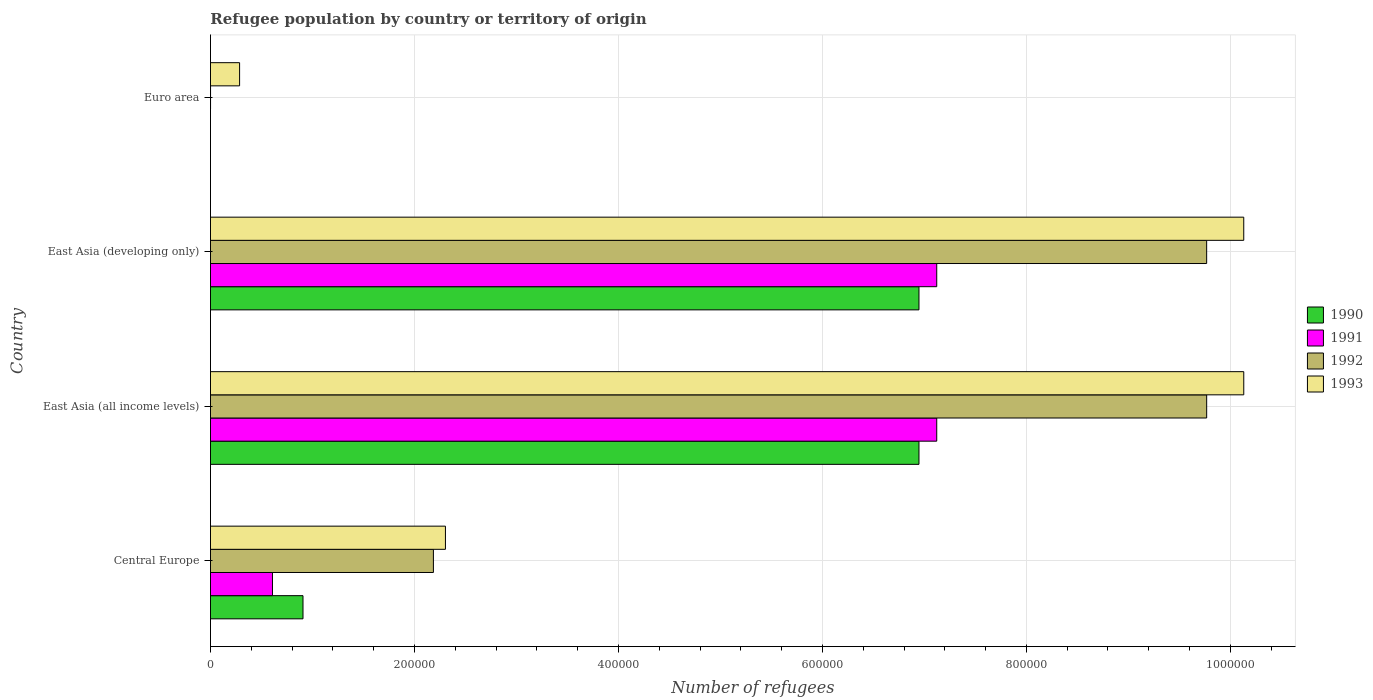How many different coloured bars are there?
Offer a very short reply. 4. Are the number of bars per tick equal to the number of legend labels?
Your answer should be very brief. Yes. Are the number of bars on each tick of the Y-axis equal?
Your response must be concise. Yes. What is the label of the 4th group of bars from the top?
Keep it short and to the point. Central Europe. In how many cases, is the number of bars for a given country not equal to the number of legend labels?
Keep it short and to the point. 0. What is the number of refugees in 1990 in East Asia (developing only)?
Give a very brief answer. 6.95e+05. Across all countries, what is the maximum number of refugees in 1992?
Offer a terse response. 9.77e+05. Across all countries, what is the minimum number of refugees in 1992?
Ensure brevity in your answer.  78. In which country was the number of refugees in 1993 maximum?
Keep it short and to the point. East Asia (all income levels). What is the total number of refugees in 1991 in the graph?
Your answer should be very brief. 1.48e+06. What is the difference between the number of refugees in 1991 in Central Europe and that in Euro area?
Your response must be concise. 6.08e+04. What is the difference between the number of refugees in 1991 in Euro area and the number of refugees in 1990 in Central Europe?
Your answer should be very brief. -9.07e+04. What is the average number of refugees in 1990 per country?
Offer a very short reply. 3.70e+05. What is the difference between the number of refugees in 1992 and number of refugees in 1990 in Central Europe?
Offer a very short reply. 1.28e+05. What is the ratio of the number of refugees in 1993 in East Asia (all income levels) to that in East Asia (developing only)?
Offer a very short reply. 1. What is the difference between the highest and the lowest number of refugees in 1991?
Keep it short and to the point. 7.12e+05. In how many countries, is the number of refugees in 1993 greater than the average number of refugees in 1993 taken over all countries?
Keep it short and to the point. 2. Is the sum of the number of refugees in 1993 in East Asia (developing only) and Euro area greater than the maximum number of refugees in 1990 across all countries?
Provide a short and direct response. Yes. Is it the case that in every country, the sum of the number of refugees in 1990 and number of refugees in 1991 is greater than the sum of number of refugees in 1993 and number of refugees in 1992?
Ensure brevity in your answer.  No. What does the 4th bar from the top in Central Europe represents?
Give a very brief answer. 1990. How many bars are there?
Offer a terse response. 16. Are all the bars in the graph horizontal?
Give a very brief answer. Yes. How many countries are there in the graph?
Provide a short and direct response. 4. Are the values on the major ticks of X-axis written in scientific E-notation?
Provide a short and direct response. No. Does the graph contain grids?
Your response must be concise. Yes. How many legend labels are there?
Offer a very short reply. 4. How are the legend labels stacked?
Ensure brevity in your answer.  Vertical. What is the title of the graph?
Your answer should be very brief. Refugee population by country or territory of origin. Does "1968" appear as one of the legend labels in the graph?
Ensure brevity in your answer.  No. What is the label or title of the X-axis?
Offer a very short reply. Number of refugees. What is the Number of refugees in 1990 in Central Europe?
Give a very brief answer. 9.07e+04. What is the Number of refugees in 1991 in Central Europe?
Your answer should be very brief. 6.08e+04. What is the Number of refugees of 1992 in Central Europe?
Offer a very short reply. 2.19e+05. What is the Number of refugees in 1993 in Central Europe?
Your answer should be compact. 2.30e+05. What is the Number of refugees of 1990 in East Asia (all income levels)?
Your answer should be compact. 6.95e+05. What is the Number of refugees in 1991 in East Asia (all income levels)?
Your response must be concise. 7.12e+05. What is the Number of refugees in 1992 in East Asia (all income levels)?
Keep it short and to the point. 9.77e+05. What is the Number of refugees in 1993 in East Asia (all income levels)?
Your answer should be compact. 1.01e+06. What is the Number of refugees of 1990 in East Asia (developing only)?
Keep it short and to the point. 6.95e+05. What is the Number of refugees in 1991 in East Asia (developing only)?
Provide a short and direct response. 7.12e+05. What is the Number of refugees of 1992 in East Asia (developing only)?
Offer a very short reply. 9.77e+05. What is the Number of refugees in 1993 in East Asia (developing only)?
Provide a short and direct response. 1.01e+06. What is the Number of refugees in 1993 in Euro area?
Give a very brief answer. 2.86e+04. Across all countries, what is the maximum Number of refugees of 1990?
Your response must be concise. 6.95e+05. Across all countries, what is the maximum Number of refugees in 1991?
Ensure brevity in your answer.  7.12e+05. Across all countries, what is the maximum Number of refugees of 1992?
Provide a succinct answer. 9.77e+05. Across all countries, what is the maximum Number of refugees in 1993?
Your response must be concise. 1.01e+06. Across all countries, what is the minimum Number of refugees in 1991?
Your response must be concise. 17. Across all countries, what is the minimum Number of refugees in 1992?
Give a very brief answer. 78. Across all countries, what is the minimum Number of refugees in 1993?
Your answer should be very brief. 2.86e+04. What is the total Number of refugees in 1990 in the graph?
Your response must be concise. 1.48e+06. What is the total Number of refugees in 1991 in the graph?
Offer a terse response. 1.48e+06. What is the total Number of refugees of 1992 in the graph?
Provide a succinct answer. 2.17e+06. What is the total Number of refugees in 1993 in the graph?
Your response must be concise. 2.29e+06. What is the difference between the Number of refugees in 1990 in Central Europe and that in East Asia (all income levels)?
Keep it short and to the point. -6.04e+05. What is the difference between the Number of refugees in 1991 in Central Europe and that in East Asia (all income levels)?
Your answer should be compact. -6.51e+05. What is the difference between the Number of refugees of 1992 in Central Europe and that in East Asia (all income levels)?
Provide a short and direct response. -7.58e+05. What is the difference between the Number of refugees in 1993 in Central Europe and that in East Asia (all income levels)?
Keep it short and to the point. -7.83e+05. What is the difference between the Number of refugees of 1990 in Central Europe and that in East Asia (developing only)?
Ensure brevity in your answer.  -6.04e+05. What is the difference between the Number of refugees of 1991 in Central Europe and that in East Asia (developing only)?
Give a very brief answer. -6.51e+05. What is the difference between the Number of refugees in 1992 in Central Europe and that in East Asia (developing only)?
Ensure brevity in your answer.  -7.58e+05. What is the difference between the Number of refugees of 1993 in Central Europe and that in East Asia (developing only)?
Keep it short and to the point. -7.83e+05. What is the difference between the Number of refugees in 1990 in Central Europe and that in Euro area?
Provide a short and direct response. 9.07e+04. What is the difference between the Number of refugees in 1991 in Central Europe and that in Euro area?
Make the answer very short. 6.08e+04. What is the difference between the Number of refugees in 1992 in Central Europe and that in Euro area?
Provide a short and direct response. 2.19e+05. What is the difference between the Number of refugees of 1993 in Central Europe and that in Euro area?
Give a very brief answer. 2.02e+05. What is the difference between the Number of refugees in 1990 in East Asia (all income levels) and that in East Asia (developing only)?
Give a very brief answer. 0. What is the difference between the Number of refugees of 1991 in East Asia (all income levels) and that in East Asia (developing only)?
Your answer should be very brief. 5. What is the difference between the Number of refugees in 1990 in East Asia (all income levels) and that in Euro area?
Offer a very short reply. 6.95e+05. What is the difference between the Number of refugees of 1991 in East Asia (all income levels) and that in Euro area?
Offer a very short reply. 7.12e+05. What is the difference between the Number of refugees of 1992 in East Asia (all income levels) and that in Euro area?
Your answer should be very brief. 9.77e+05. What is the difference between the Number of refugees of 1993 in East Asia (all income levels) and that in Euro area?
Your response must be concise. 9.85e+05. What is the difference between the Number of refugees in 1990 in East Asia (developing only) and that in Euro area?
Your answer should be very brief. 6.95e+05. What is the difference between the Number of refugees of 1991 in East Asia (developing only) and that in Euro area?
Provide a succinct answer. 7.12e+05. What is the difference between the Number of refugees of 1992 in East Asia (developing only) and that in Euro area?
Your response must be concise. 9.77e+05. What is the difference between the Number of refugees of 1993 in East Asia (developing only) and that in Euro area?
Offer a terse response. 9.85e+05. What is the difference between the Number of refugees of 1990 in Central Europe and the Number of refugees of 1991 in East Asia (all income levels)?
Ensure brevity in your answer.  -6.21e+05. What is the difference between the Number of refugees of 1990 in Central Europe and the Number of refugees of 1992 in East Asia (all income levels)?
Offer a very short reply. -8.86e+05. What is the difference between the Number of refugees of 1990 in Central Europe and the Number of refugees of 1993 in East Asia (all income levels)?
Keep it short and to the point. -9.22e+05. What is the difference between the Number of refugees of 1991 in Central Europe and the Number of refugees of 1992 in East Asia (all income levels)?
Your answer should be compact. -9.16e+05. What is the difference between the Number of refugees of 1991 in Central Europe and the Number of refugees of 1993 in East Asia (all income levels)?
Ensure brevity in your answer.  -9.52e+05. What is the difference between the Number of refugees of 1992 in Central Europe and the Number of refugees of 1993 in East Asia (all income levels)?
Your answer should be very brief. -7.95e+05. What is the difference between the Number of refugees of 1990 in Central Europe and the Number of refugees of 1991 in East Asia (developing only)?
Make the answer very short. -6.21e+05. What is the difference between the Number of refugees of 1990 in Central Europe and the Number of refugees of 1992 in East Asia (developing only)?
Your answer should be very brief. -8.86e+05. What is the difference between the Number of refugees of 1990 in Central Europe and the Number of refugees of 1993 in East Asia (developing only)?
Your answer should be very brief. -9.22e+05. What is the difference between the Number of refugees of 1991 in Central Europe and the Number of refugees of 1992 in East Asia (developing only)?
Keep it short and to the point. -9.16e+05. What is the difference between the Number of refugees in 1991 in Central Europe and the Number of refugees in 1993 in East Asia (developing only)?
Make the answer very short. -9.52e+05. What is the difference between the Number of refugees in 1992 in Central Europe and the Number of refugees in 1993 in East Asia (developing only)?
Provide a succinct answer. -7.95e+05. What is the difference between the Number of refugees in 1990 in Central Europe and the Number of refugees in 1991 in Euro area?
Your response must be concise. 9.07e+04. What is the difference between the Number of refugees in 1990 in Central Europe and the Number of refugees in 1992 in Euro area?
Ensure brevity in your answer.  9.07e+04. What is the difference between the Number of refugees in 1990 in Central Europe and the Number of refugees in 1993 in Euro area?
Keep it short and to the point. 6.22e+04. What is the difference between the Number of refugees of 1991 in Central Europe and the Number of refugees of 1992 in Euro area?
Your response must be concise. 6.07e+04. What is the difference between the Number of refugees of 1991 in Central Europe and the Number of refugees of 1993 in Euro area?
Your answer should be very brief. 3.22e+04. What is the difference between the Number of refugees of 1992 in Central Europe and the Number of refugees of 1993 in Euro area?
Provide a succinct answer. 1.90e+05. What is the difference between the Number of refugees of 1990 in East Asia (all income levels) and the Number of refugees of 1991 in East Asia (developing only)?
Your response must be concise. -1.74e+04. What is the difference between the Number of refugees of 1990 in East Asia (all income levels) and the Number of refugees of 1992 in East Asia (developing only)?
Provide a short and direct response. -2.82e+05. What is the difference between the Number of refugees of 1990 in East Asia (all income levels) and the Number of refugees of 1993 in East Asia (developing only)?
Provide a succinct answer. -3.18e+05. What is the difference between the Number of refugees in 1991 in East Asia (all income levels) and the Number of refugees in 1992 in East Asia (developing only)?
Provide a succinct answer. -2.65e+05. What is the difference between the Number of refugees in 1991 in East Asia (all income levels) and the Number of refugees in 1993 in East Asia (developing only)?
Keep it short and to the point. -3.01e+05. What is the difference between the Number of refugees of 1992 in East Asia (all income levels) and the Number of refugees of 1993 in East Asia (developing only)?
Make the answer very short. -3.64e+04. What is the difference between the Number of refugees in 1990 in East Asia (all income levels) and the Number of refugees in 1991 in Euro area?
Offer a very short reply. 6.95e+05. What is the difference between the Number of refugees of 1990 in East Asia (all income levels) and the Number of refugees of 1992 in Euro area?
Make the answer very short. 6.95e+05. What is the difference between the Number of refugees in 1990 in East Asia (all income levels) and the Number of refugees in 1993 in Euro area?
Your response must be concise. 6.66e+05. What is the difference between the Number of refugees in 1991 in East Asia (all income levels) and the Number of refugees in 1992 in Euro area?
Provide a short and direct response. 7.12e+05. What is the difference between the Number of refugees of 1991 in East Asia (all income levels) and the Number of refugees of 1993 in Euro area?
Your answer should be very brief. 6.84e+05. What is the difference between the Number of refugees in 1992 in East Asia (all income levels) and the Number of refugees in 1993 in Euro area?
Your answer should be very brief. 9.48e+05. What is the difference between the Number of refugees of 1990 in East Asia (developing only) and the Number of refugees of 1991 in Euro area?
Make the answer very short. 6.95e+05. What is the difference between the Number of refugees of 1990 in East Asia (developing only) and the Number of refugees of 1992 in Euro area?
Your answer should be compact. 6.95e+05. What is the difference between the Number of refugees in 1990 in East Asia (developing only) and the Number of refugees in 1993 in Euro area?
Offer a terse response. 6.66e+05. What is the difference between the Number of refugees in 1991 in East Asia (developing only) and the Number of refugees in 1992 in Euro area?
Keep it short and to the point. 7.12e+05. What is the difference between the Number of refugees of 1991 in East Asia (developing only) and the Number of refugees of 1993 in Euro area?
Ensure brevity in your answer.  6.84e+05. What is the difference between the Number of refugees of 1992 in East Asia (developing only) and the Number of refugees of 1993 in Euro area?
Your answer should be compact. 9.48e+05. What is the average Number of refugees in 1990 per country?
Make the answer very short. 3.70e+05. What is the average Number of refugees in 1991 per country?
Provide a short and direct response. 3.71e+05. What is the average Number of refugees in 1992 per country?
Your response must be concise. 5.43e+05. What is the average Number of refugees of 1993 per country?
Offer a very short reply. 5.71e+05. What is the difference between the Number of refugees in 1990 and Number of refugees in 1991 in Central Europe?
Your answer should be compact. 2.99e+04. What is the difference between the Number of refugees in 1990 and Number of refugees in 1992 in Central Europe?
Give a very brief answer. -1.28e+05. What is the difference between the Number of refugees of 1990 and Number of refugees of 1993 in Central Europe?
Make the answer very short. -1.40e+05. What is the difference between the Number of refugees of 1991 and Number of refugees of 1992 in Central Europe?
Offer a terse response. -1.58e+05. What is the difference between the Number of refugees of 1991 and Number of refugees of 1993 in Central Europe?
Your answer should be very brief. -1.70e+05. What is the difference between the Number of refugees in 1992 and Number of refugees in 1993 in Central Europe?
Keep it short and to the point. -1.18e+04. What is the difference between the Number of refugees in 1990 and Number of refugees in 1991 in East Asia (all income levels)?
Offer a very short reply. -1.74e+04. What is the difference between the Number of refugees in 1990 and Number of refugees in 1992 in East Asia (all income levels)?
Your answer should be very brief. -2.82e+05. What is the difference between the Number of refugees in 1990 and Number of refugees in 1993 in East Asia (all income levels)?
Offer a terse response. -3.18e+05. What is the difference between the Number of refugees in 1991 and Number of refugees in 1992 in East Asia (all income levels)?
Your response must be concise. -2.65e+05. What is the difference between the Number of refugees of 1991 and Number of refugees of 1993 in East Asia (all income levels)?
Your answer should be very brief. -3.01e+05. What is the difference between the Number of refugees of 1992 and Number of refugees of 1993 in East Asia (all income levels)?
Offer a terse response. -3.64e+04. What is the difference between the Number of refugees of 1990 and Number of refugees of 1991 in East Asia (developing only)?
Your response must be concise. -1.74e+04. What is the difference between the Number of refugees of 1990 and Number of refugees of 1992 in East Asia (developing only)?
Offer a very short reply. -2.82e+05. What is the difference between the Number of refugees of 1990 and Number of refugees of 1993 in East Asia (developing only)?
Your response must be concise. -3.18e+05. What is the difference between the Number of refugees of 1991 and Number of refugees of 1992 in East Asia (developing only)?
Provide a succinct answer. -2.65e+05. What is the difference between the Number of refugees in 1991 and Number of refugees in 1993 in East Asia (developing only)?
Keep it short and to the point. -3.01e+05. What is the difference between the Number of refugees of 1992 and Number of refugees of 1993 in East Asia (developing only)?
Your answer should be very brief. -3.64e+04. What is the difference between the Number of refugees of 1990 and Number of refugees of 1991 in Euro area?
Your answer should be very brief. 15. What is the difference between the Number of refugees in 1990 and Number of refugees in 1992 in Euro area?
Keep it short and to the point. -46. What is the difference between the Number of refugees of 1990 and Number of refugees of 1993 in Euro area?
Your answer should be compact. -2.85e+04. What is the difference between the Number of refugees of 1991 and Number of refugees of 1992 in Euro area?
Your answer should be compact. -61. What is the difference between the Number of refugees of 1991 and Number of refugees of 1993 in Euro area?
Your answer should be compact. -2.85e+04. What is the difference between the Number of refugees in 1992 and Number of refugees in 1993 in Euro area?
Offer a terse response. -2.85e+04. What is the ratio of the Number of refugees in 1990 in Central Europe to that in East Asia (all income levels)?
Give a very brief answer. 0.13. What is the ratio of the Number of refugees in 1991 in Central Europe to that in East Asia (all income levels)?
Keep it short and to the point. 0.09. What is the ratio of the Number of refugees of 1992 in Central Europe to that in East Asia (all income levels)?
Offer a terse response. 0.22. What is the ratio of the Number of refugees of 1993 in Central Europe to that in East Asia (all income levels)?
Offer a very short reply. 0.23. What is the ratio of the Number of refugees of 1990 in Central Europe to that in East Asia (developing only)?
Your answer should be very brief. 0.13. What is the ratio of the Number of refugees of 1991 in Central Europe to that in East Asia (developing only)?
Offer a very short reply. 0.09. What is the ratio of the Number of refugees in 1992 in Central Europe to that in East Asia (developing only)?
Ensure brevity in your answer.  0.22. What is the ratio of the Number of refugees of 1993 in Central Europe to that in East Asia (developing only)?
Give a very brief answer. 0.23. What is the ratio of the Number of refugees of 1990 in Central Europe to that in Euro area?
Your answer should be compact. 2835.31. What is the ratio of the Number of refugees of 1991 in Central Europe to that in Euro area?
Ensure brevity in your answer.  3575.59. What is the ratio of the Number of refugees in 1992 in Central Europe to that in Euro area?
Provide a succinct answer. 2802.29. What is the ratio of the Number of refugees in 1993 in Central Europe to that in Euro area?
Offer a terse response. 8.07. What is the ratio of the Number of refugees in 1991 in East Asia (all income levels) to that in East Asia (developing only)?
Provide a short and direct response. 1. What is the ratio of the Number of refugees in 1992 in East Asia (all income levels) to that in East Asia (developing only)?
Ensure brevity in your answer.  1. What is the ratio of the Number of refugees in 1990 in East Asia (all income levels) to that in Euro area?
Offer a very short reply. 2.17e+04. What is the ratio of the Number of refugees in 1991 in East Asia (all income levels) to that in Euro area?
Provide a succinct answer. 4.19e+04. What is the ratio of the Number of refugees of 1992 in East Asia (all income levels) to that in Euro area?
Make the answer very short. 1.25e+04. What is the ratio of the Number of refugees in 1993 in East Asia (all income levels) to that in Euro area?
Keep it short and to the point. 35.49. What is the ratio of the Number of refugees of 1990 in East Asia (developing only) to that in Euro area?
Your answer should be compact. 2.17e+04. What is the ratio of the Number of refugees of 1991 in East Asia (developing only) to that in Euro area?
Make the answer very short. 4.19e+04. What is the ratio of the Number of refugees in 1992 in East Asia (developing only) to that in Euro area?
Give a very brief answer. 1.25e+04. What is the ratio of the Number of refugees in 1993 in East Asia (developing only) to that in Euro area?
Give a very brief answer. 35.48. What is the difference between the highest and the second highest Number of refugees in 1990?
Provide a succinct answer. 0. What is the difference between the highest and the second highest Number of refugees of 1993?
Provide a short and direct response. 10. What is the difference between the highest and the lowest Number of refugees in 1990?
Keep it short and to the point. 6.95e+05. What is the difference between the highest and the lowest Number of refugees in 1991?
Your response must be concise. 7.12e+05. What is the difference between the highest and the lowest Number of refugees of 1992?
Provide a succinct answer. 9.77e+05. What is the difference between the highest and the lowest Number of refugees of 1993?
Provide a short and direct response. 9.85e+05. 